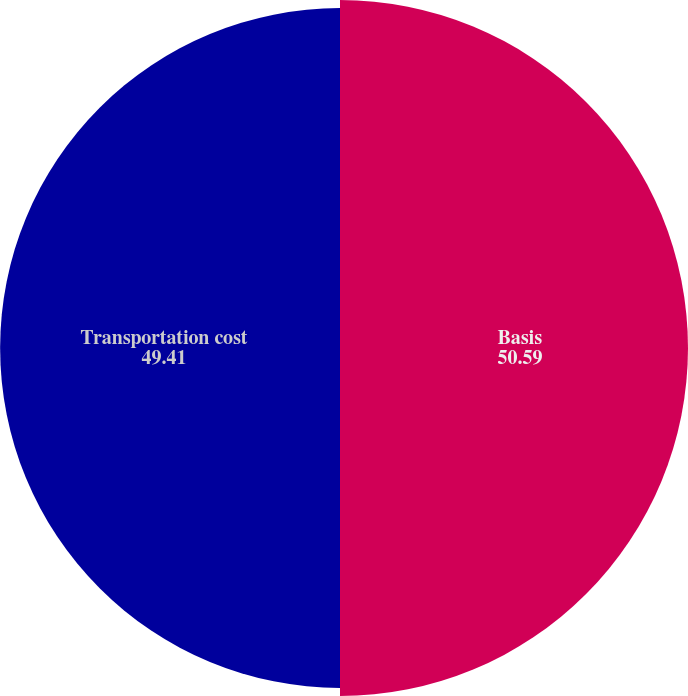Convert chart. <chart><loc_0><loc_0><loc_500><loc_500><pie_chart><fcel>Basis<fcel>Transportation cost<nl><fcel>50.59%<fcel>49.41%<nl></chart> 